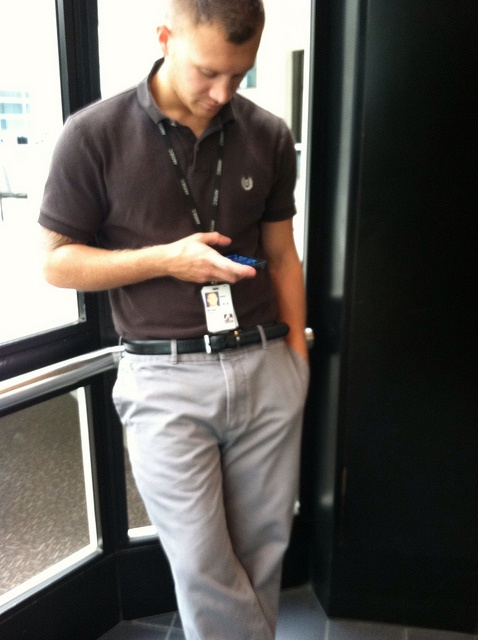Describe the objects in this image and their specific colors. I can see people in white, black, gray, lightgray, and darkgray tones and cell phone in white, black, navy, blue, and darkblue tones in this image. 